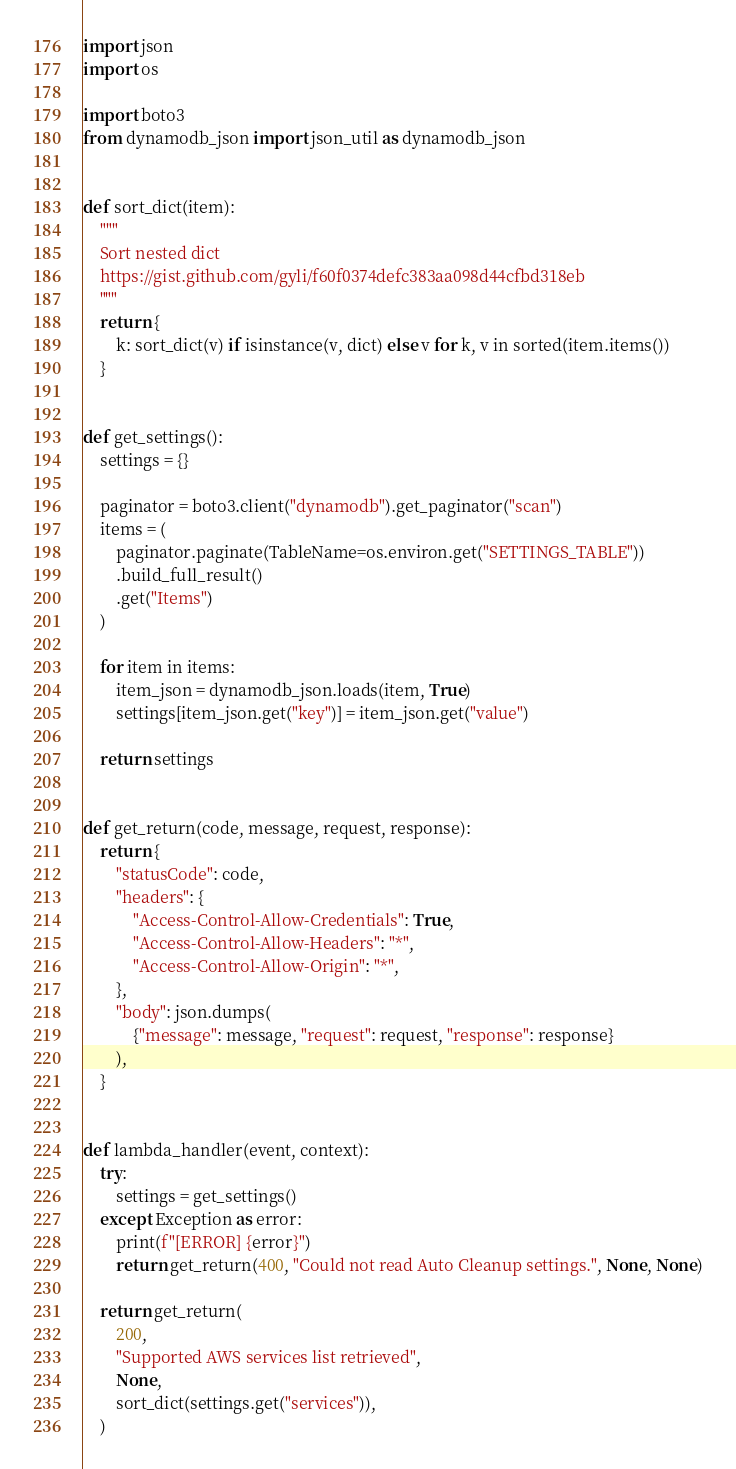<code> <loc_0><loc_0><loc_500><loc_500><_Python_>import json
import os

import boto3
from dynamodb_json import json_util as dynamodb_json


def sort_dict(item):
    """
    Sort nested dict
    https://gist.github.com/gyli/f60f0374defc383aa098d44cfbd318eb
    """
    return {
        k: sort_dict(v) if isinstance(v, dict) else v for k, v in sorted(item.items())
    }


def get_settings():
    settings = {}

    paginator = boto3.client("dynamodb").get_paginator("scan")
    items = (
        paginator.paginate(TableName=os.environ.get("SETTINGS_TABLE"))
        .build_full_result()
        .get("Items")
    )

    for item in items:
        item_json = dynamodb_json.loads(item, True)
        settings[item_json.get("key")] = item_json.get("value")

    return settings


def get_return(code, message, request, response):
    return {
        "statusCode": code,
        "headers": {
            "Access-Control-Allow-Credentials": True,
            "Access-Control-Allow-Headers": "*",
            "Access-Control-Allow-Origin": "*",
        },
        "body": json.dumps(
            {"message": message, "request": request, "response": response}
        ),
    }


def lambda_handler(event, context):
    try:
        settings = get_settings()
    except Exception as error:
        print(f"[ERROR] {error}")
        return get_return(400, "Could not read Auto Cleanup settings.", None, None)

    return get_return(
        200,
        "Supported AWS services list retrieved",
        None,
        sort_dict(settings.get("services")),
    )
</code> 